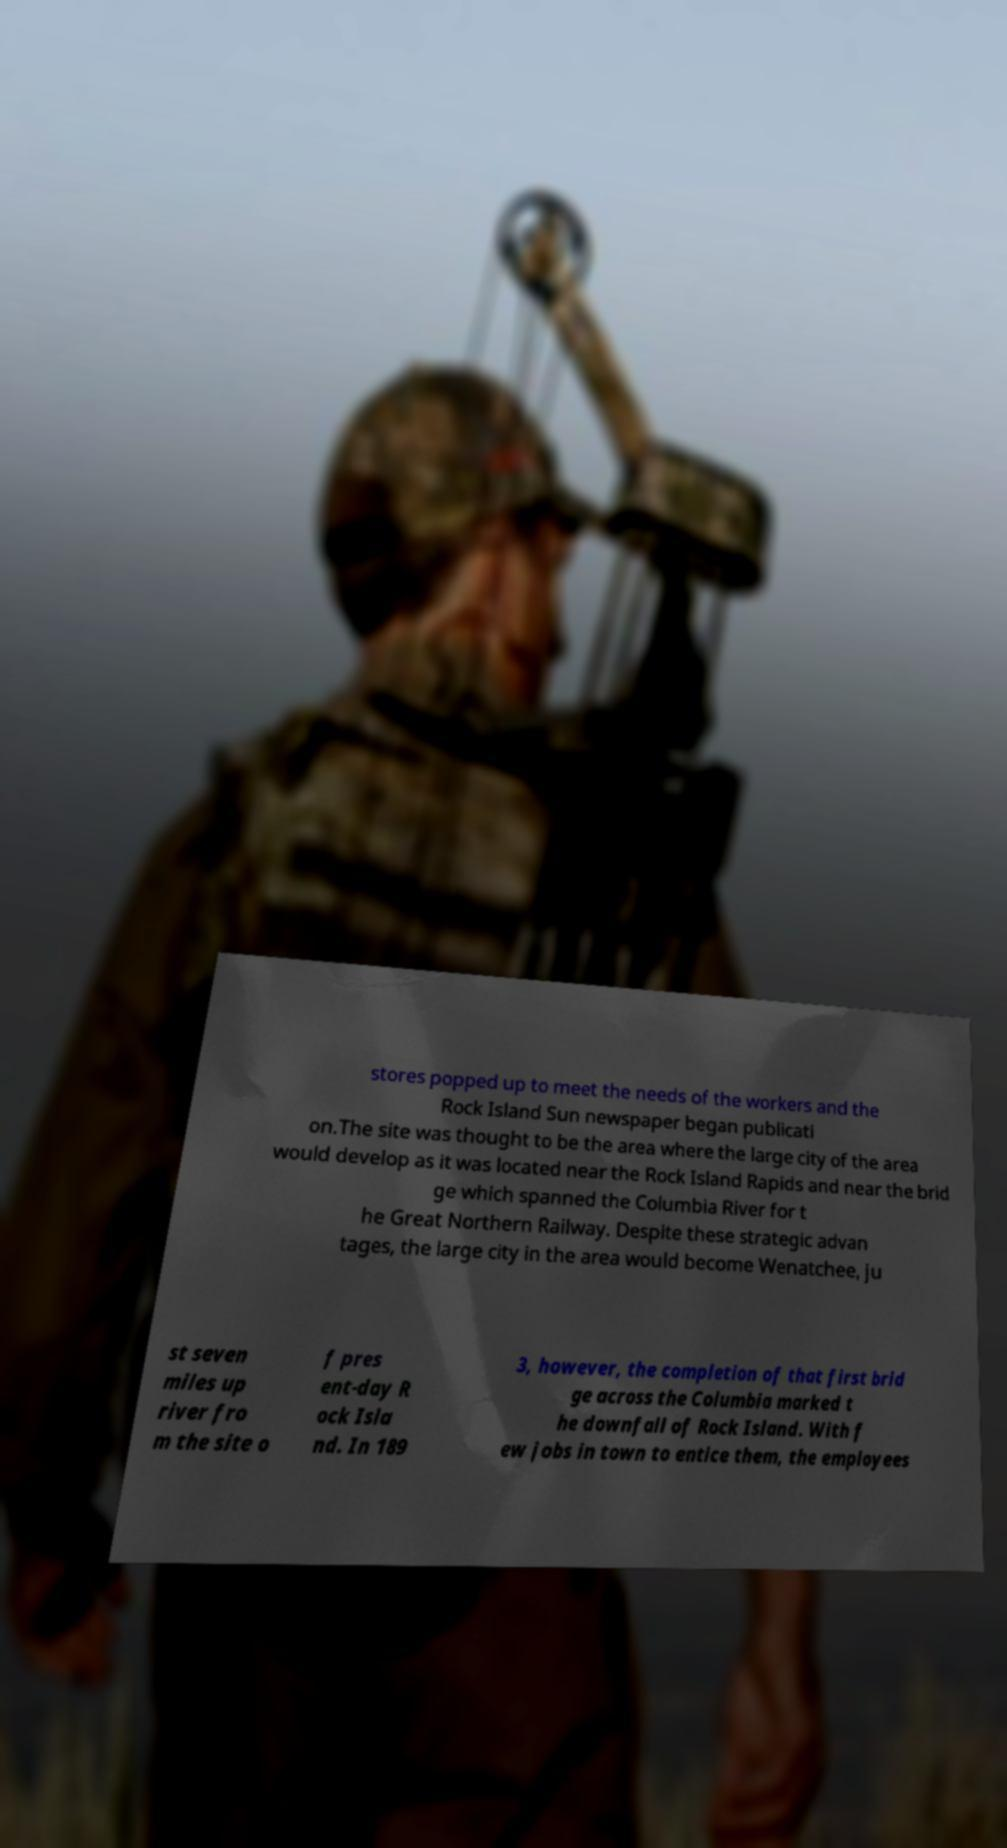I need the written content from this picture converted into text. Can you do that? stores popped up to meet the needs of the workers and the Rock Island Sun newspaper began publicati on.The site was thought to be the area where the large city of the area would develop as it was located near the Rock Island Rapids and near the brid ge which spanned the Columbia River for t he Great Northern Railway. Despite these strategic advan tages, the large city in the area would become Wenatchee, ju st seven miles up river fro m the site o f pres ent-day R ock Isla nd. In 189 3, however, the completion of that first brid ge across the Columbia marked t he downfall of Rock Island. With f ew jobs in town to entice them, the employees 